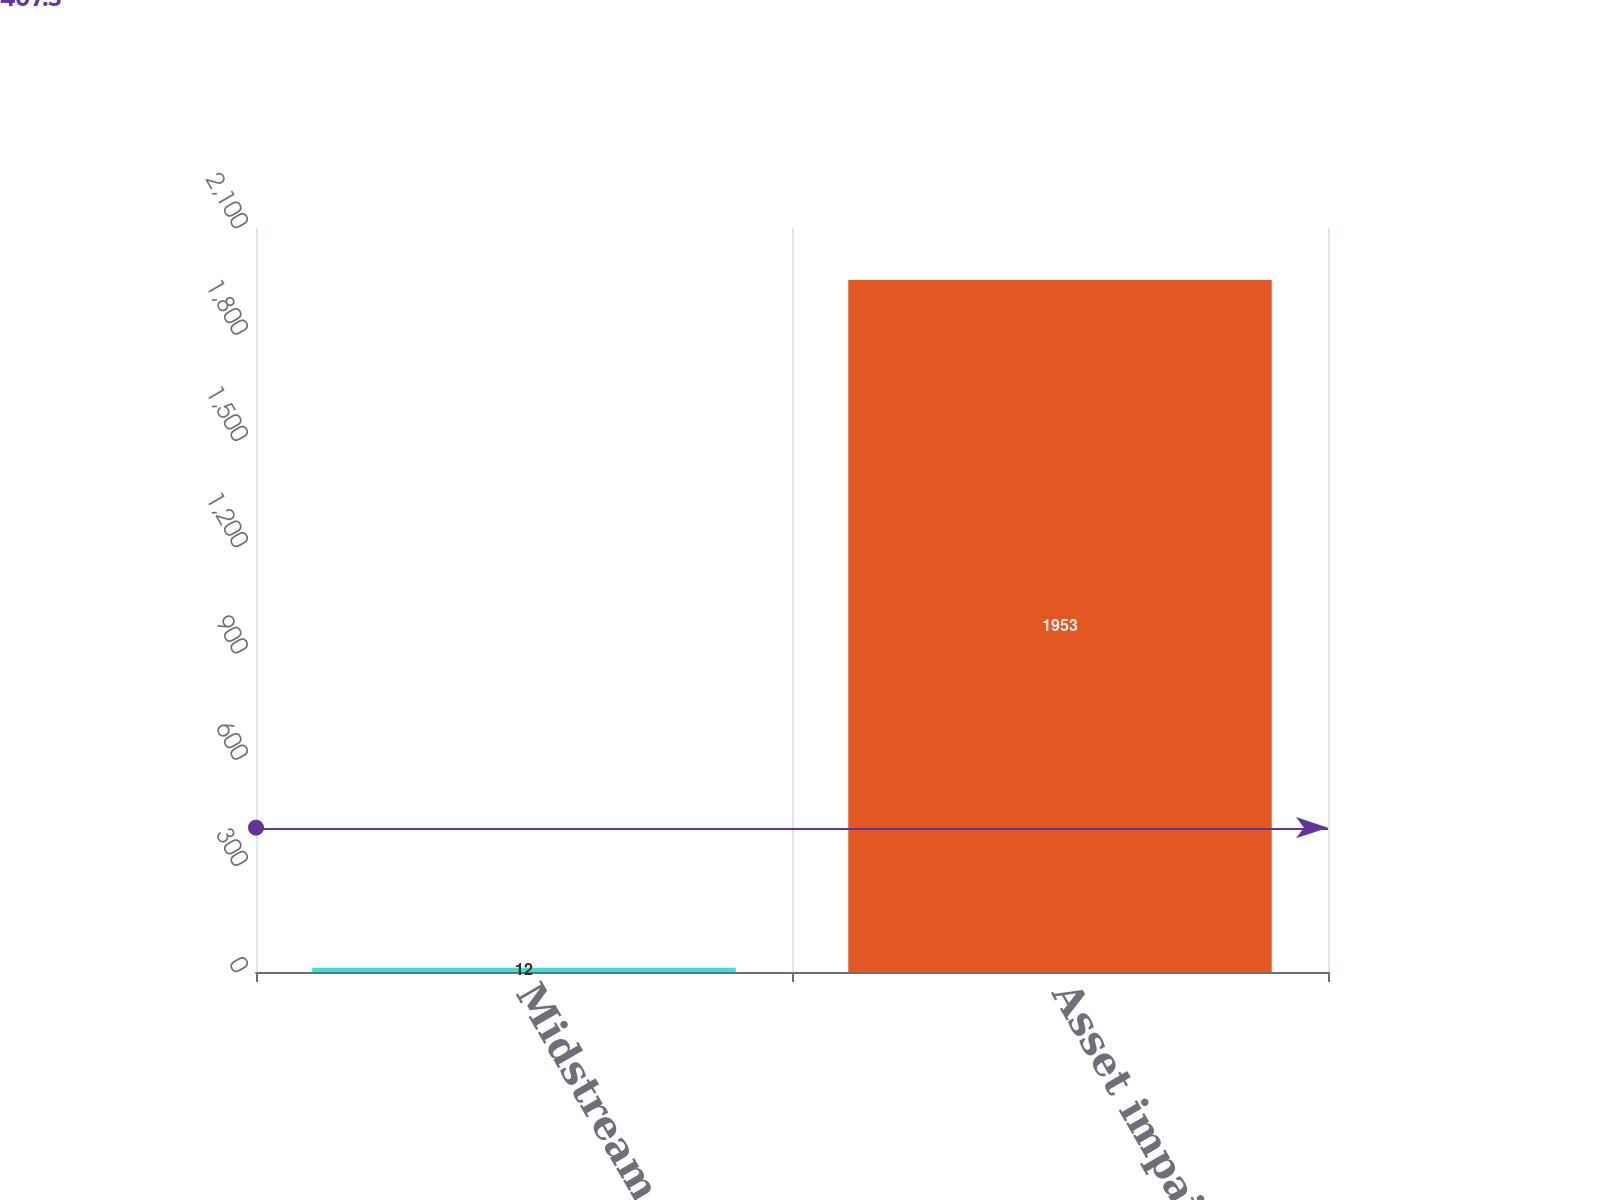Convert chart. <chart><loc_0><loc_0><loc_500><loc_500><bar_chart><fcel>Midstream assets<fcel>Asset impairments<nl><fcel>12<fcel>1953<nl></chart> 